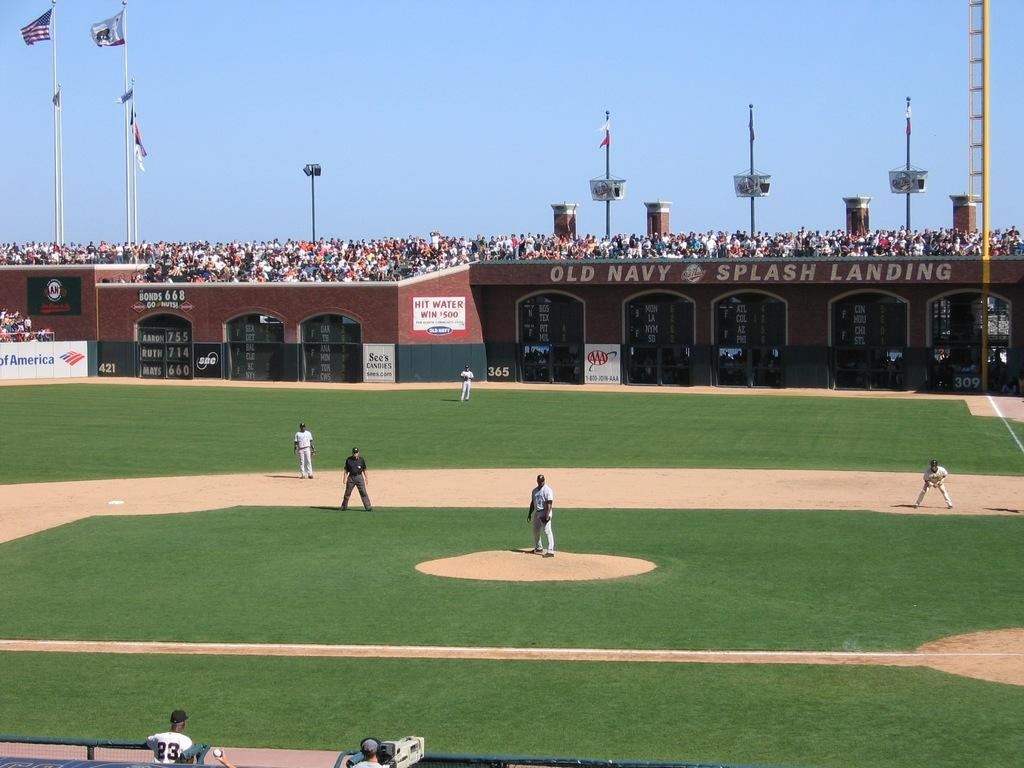<image>
Present a compact description of the photo's key features. a baseball stadium with a sign that says 'hit water win $500' 